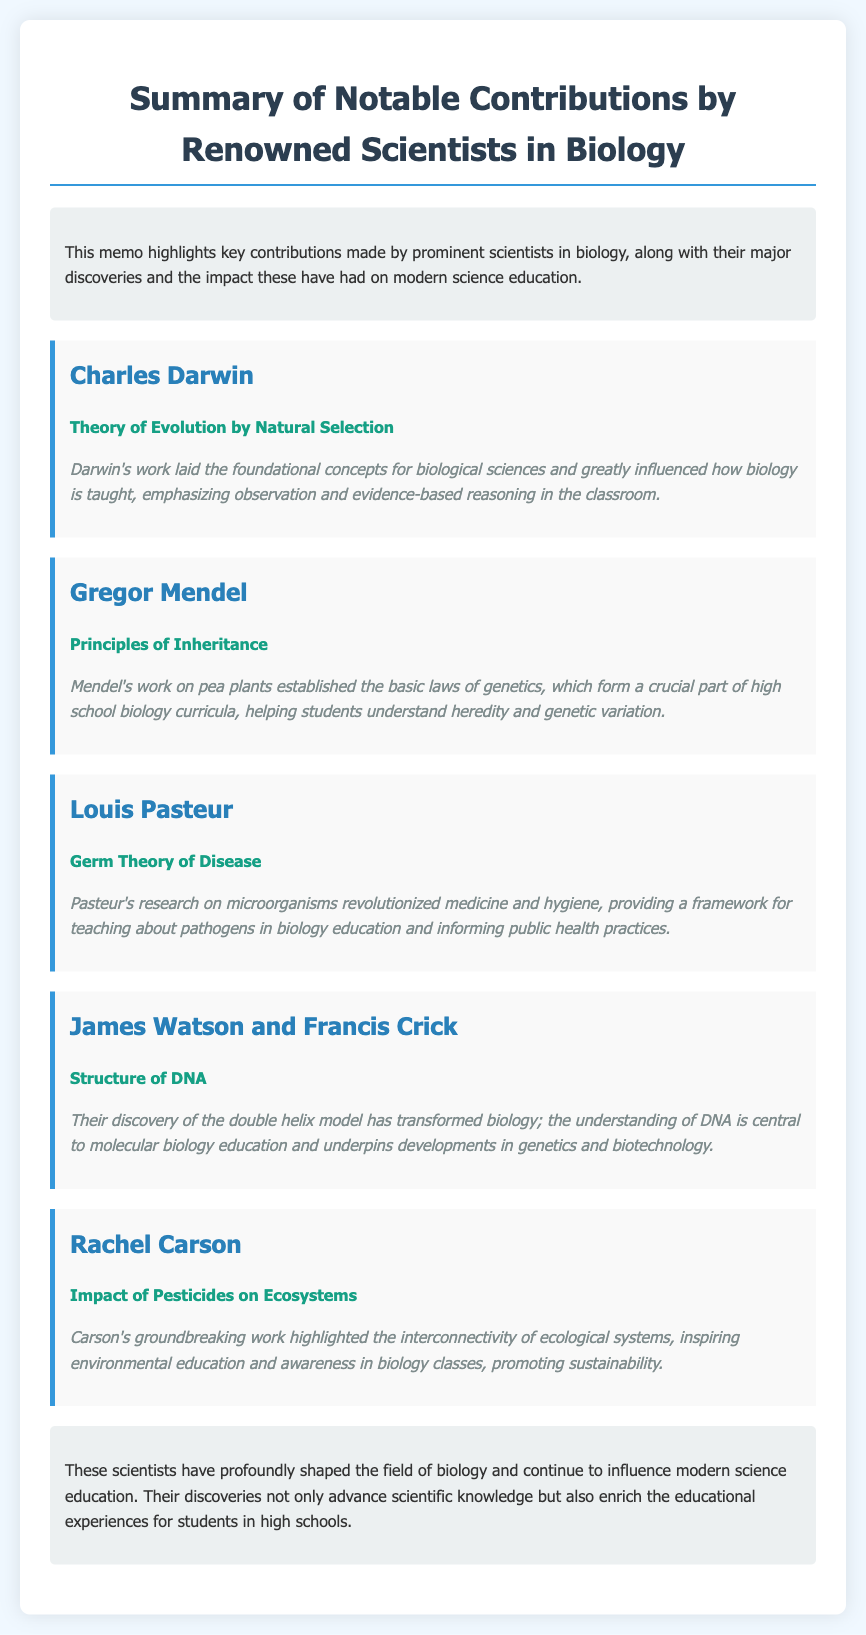What is the title of the memo? The title of the memo is displayed prominently at the top of the document.
Answer: Summary of Notable Contributions by Renowned Scientists in Biology Who proposed the Theory of Evolution? The memo explicitly states the contributions of each scientist, including Darwin's theory.
Answer: Charles Darwin What major discovery is associated with Gregor Mendel? The document specifies Mendel's significant contribution to the field of genetics.
Answer: Principles of Inheritance Which scientist discovered the Structure of DNA? The memo attributes the discovery of DNA's structure to Watson and Crick.
Answer: James Watson and Francis Crick What impact did Louis Pasteur's work have on education? The memo indicates how Pasteur's research is integrated into teaching about pathogens.
Answer: Framework for teaching about pathogens Which scientist is known for their work on pesticides and ecosystems? The document describes Rachel Carson's contribution regarding environmental awareness.
Answer: Rachel Carson What is a significant focus of modern science education mentioned in the memo? The memo discusses the impact of various discoveries on the educational curriculum in biology classes.
Answer: Observations and evidence-based reasoning How does Darwin’s work influence biology teaching? The document describes the foundational concepts introduced by Darwin for teaching biology.
Answer: Emphasizing observation and evidence-based reasoning in the classroom What theme connects all the contributions discussed in the memo? The memo highlights the overarching significance of these discoveries in enhancing educational experiences.
Answer: Influencing modern science education 